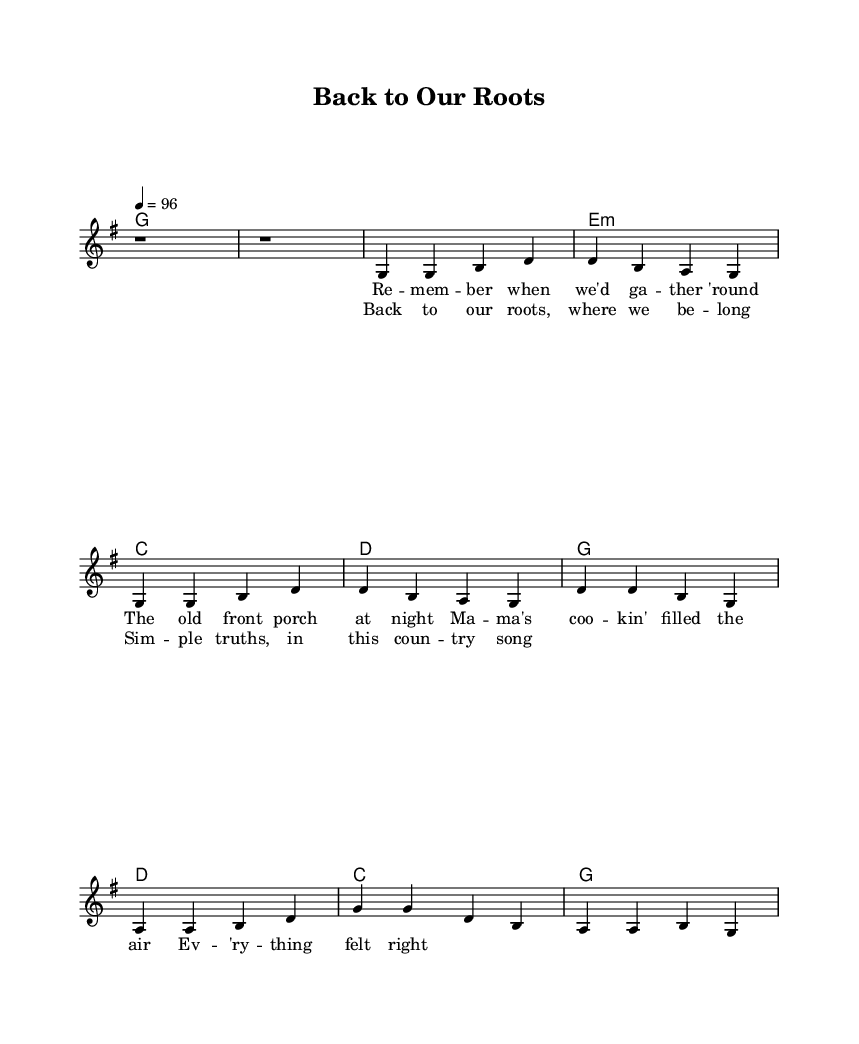What is the key signature of this music? The key signature is G major, which has one sharp (F#) and is indicated at the beginning of the staff.
Answer: G major What is the time signature of this music? The time signature is 4/4, shown as a fraction at the beginning of the piece, indicating four beats per measure.
Answer: 4/4 What is the tempo marking for this music? The tempo marking is a quarter note equals 96 beats per minute, seen at the start as a numeral indication.
Answer: 96 How many measures are in the first verse? The first verse consists of four measures, which can be counted from the melody section where each group of notes represents a measure.
Answer: 4 What chords are played during the chorus? The chords played during the chorus are G, D, C, and G, which are written in the harmonies section corresponding to the chorus lyrics.
Answer: G, D, C, G What is the thematic focus of the lyrics in this piece? The lyrics focus on themes of nostalgia and traditional family values, as indicated by the content of the lyrics describing gatherings and home comforts.
Answer: Nostalgia and family values How does the structure of this song reflect typical characteristics of country rock? The song features a straightforward verse-chorus structure with relatable themes and simple chord progressions, common in country rock music.
Answer: Verse-chorus structure and simple chords 